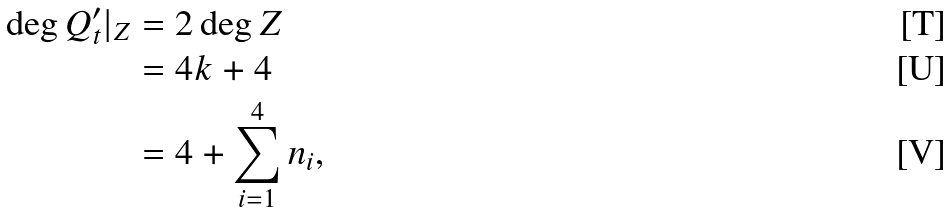Convert formula to latex. <formula><loc_0><loc_0><loc_500><loc_500>\deg Q ^ { \prime } _ { t } | _ { Z } & = 2 \deg Z \\ & = 4 k + 4 \\ & = 4 + \sum _ { i = 1 } ^ { 4 } n _ { i } ,</formula> 